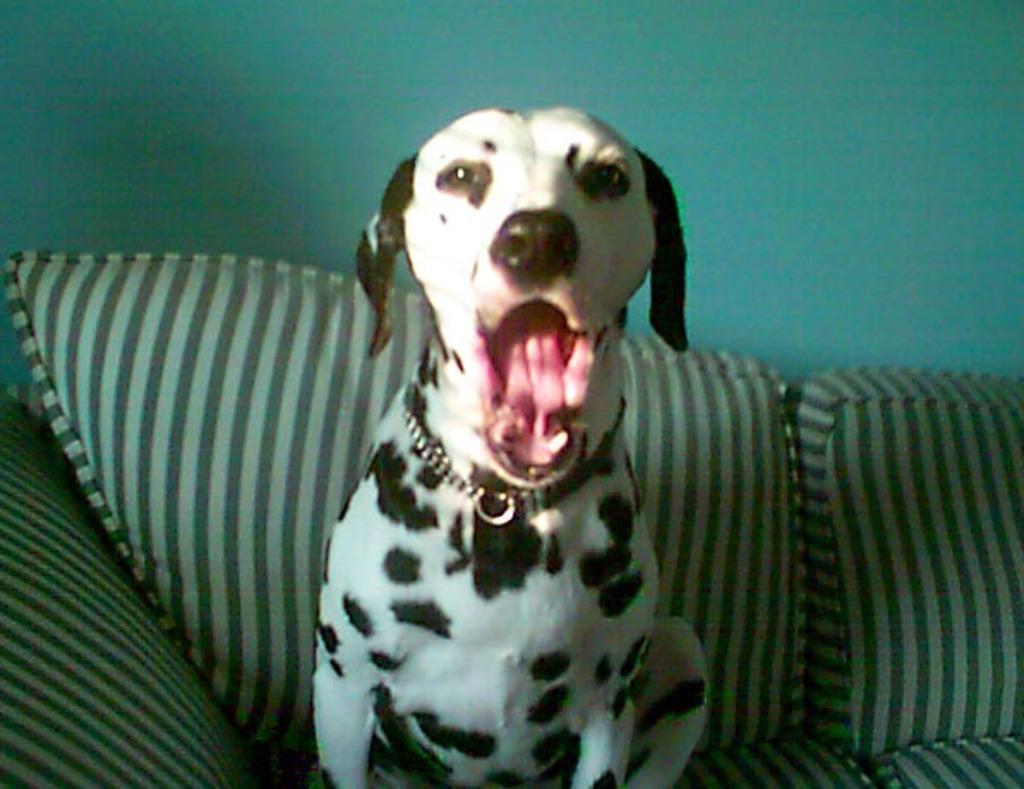In one or two sentences, can you explain what this image depicts? This image consists of a dog sitting on a sofa. In the background, there is a wall. 